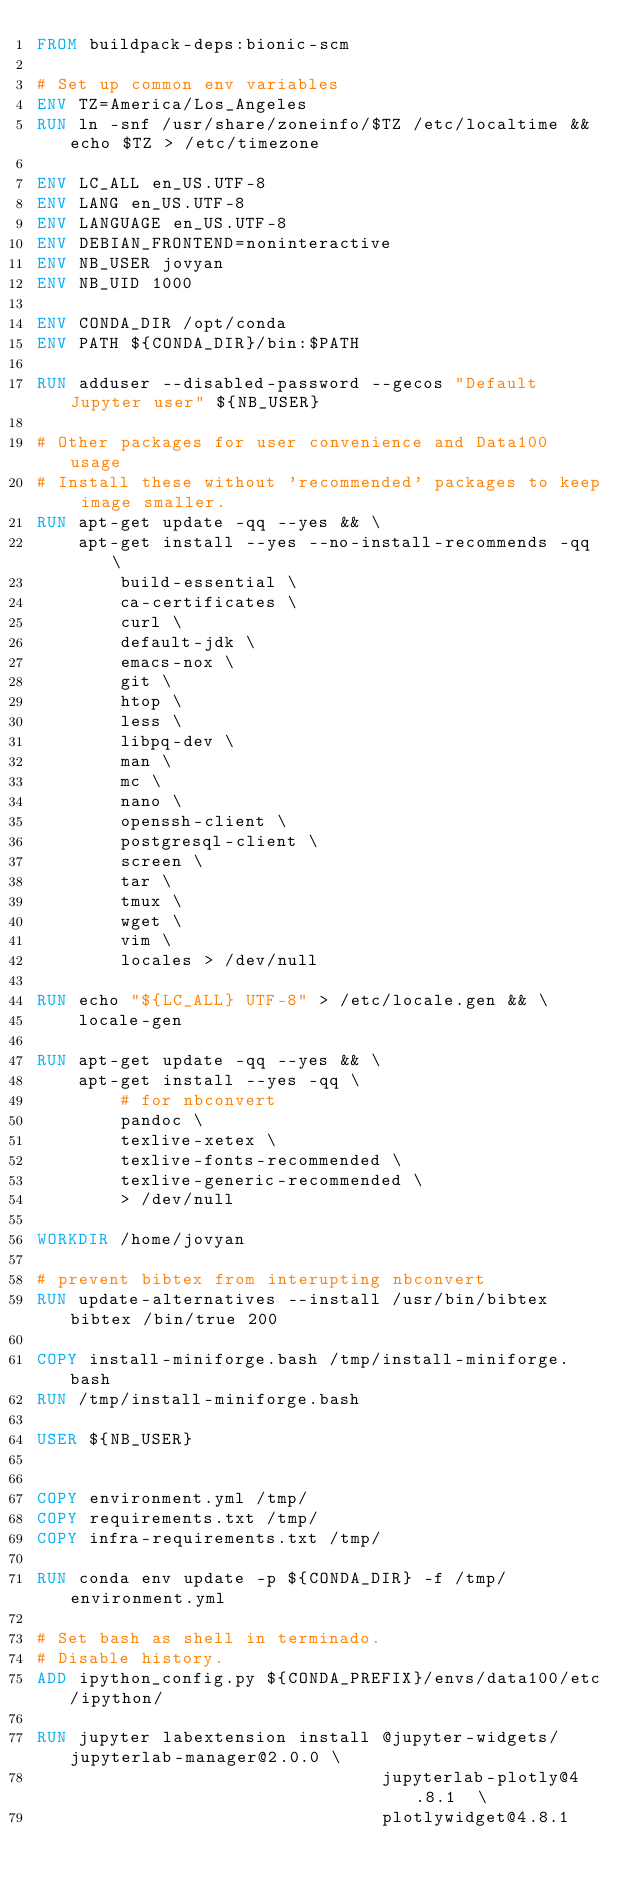Convert code to text. <code><loc_0><loc_0><loc_500><loc_500><_Dockerfile_>FROM buildpack-deps:bionic-scm

# Set up common env variables
ENV TZ=America/Los_Angeles
RUN ln -snf /usr/share/zoneinfo/$TZ /etc/localtime && echo $TZ > /etc/timezone

ENV LC_ALL en_US.UTF-8
ENV LANG en_US.UTF-8
ENV LANGUAGE en_US.UTF-8
ENV DEBIAN_FRONTEND=noninteractive
ENV NB_USER jovyan
ENV NB_UID 1000

ENV CONDA_DIR /opt/conda
ENV PATH ${CONDA_DIR}/bin:$PATH

RUN adduser --disabled-password --gecos "Default Jupyter user" ${NB_USER}

# Other packages for user convenience and Data100 usage
# Install these without 'recommended' packages to keep image smaller.
RUN apt-get update -qq --yes && \
    apt-get install --yes --no-install-recommends -qq \
        build-essential \
        ca-certificates \
        curl \
        default-jdk \
        emacs-nox \
        git \
        htop \
        less \
        libpq-dev \
        man \
        mc \
        nano \
        openssh-client \
        postgresql-client \
        screen \
        tar \
        tmux \
        wget \
        vim \
        locales > /dev/null

RUN echo "${LC_ALL} UTF-8" > /etc/locale.gen && \
    locale-gen

RUN apt-get update -qq --yes && \
    apt-get install --yes -qq \
        # for nbconvert
        pandoc \
        texlive-xetex \
        texlive-fonts-recommended \
        texlive-generic-recommended \
        > /dev/null

WORKDIR /home/jovyan

# prevent bibtex from interupting nbconvert
RUN update-alternatives --install /usr/bin/bibtex bibtex /bin/true 200

COPY install-miniforge.bash /tmp/install-miniforge.bash
RUN /tmp/install-miniforge.bash

USER ${NB_USER}


COPY environment.yml /tmp/
COPY requirements.txt /tmp/
COPY infra-requirements.txt /tmp/

RUN conda env update -p ${CONDA_DIR} -f /tmp/environment.yml

# Set bash as shell in terminado.
# Disable history.
ADD ipython_config.py ${CONDA_PREFIX}/envs/data100/etc/ipython/

RUN jupyter labextension install @jupyter-widgets/jupyterlab-manager@2.0.0 \
                                 jupyterlab-plotly@4.8.1  \
                                 plotlywidget@4.8.1
</code> 